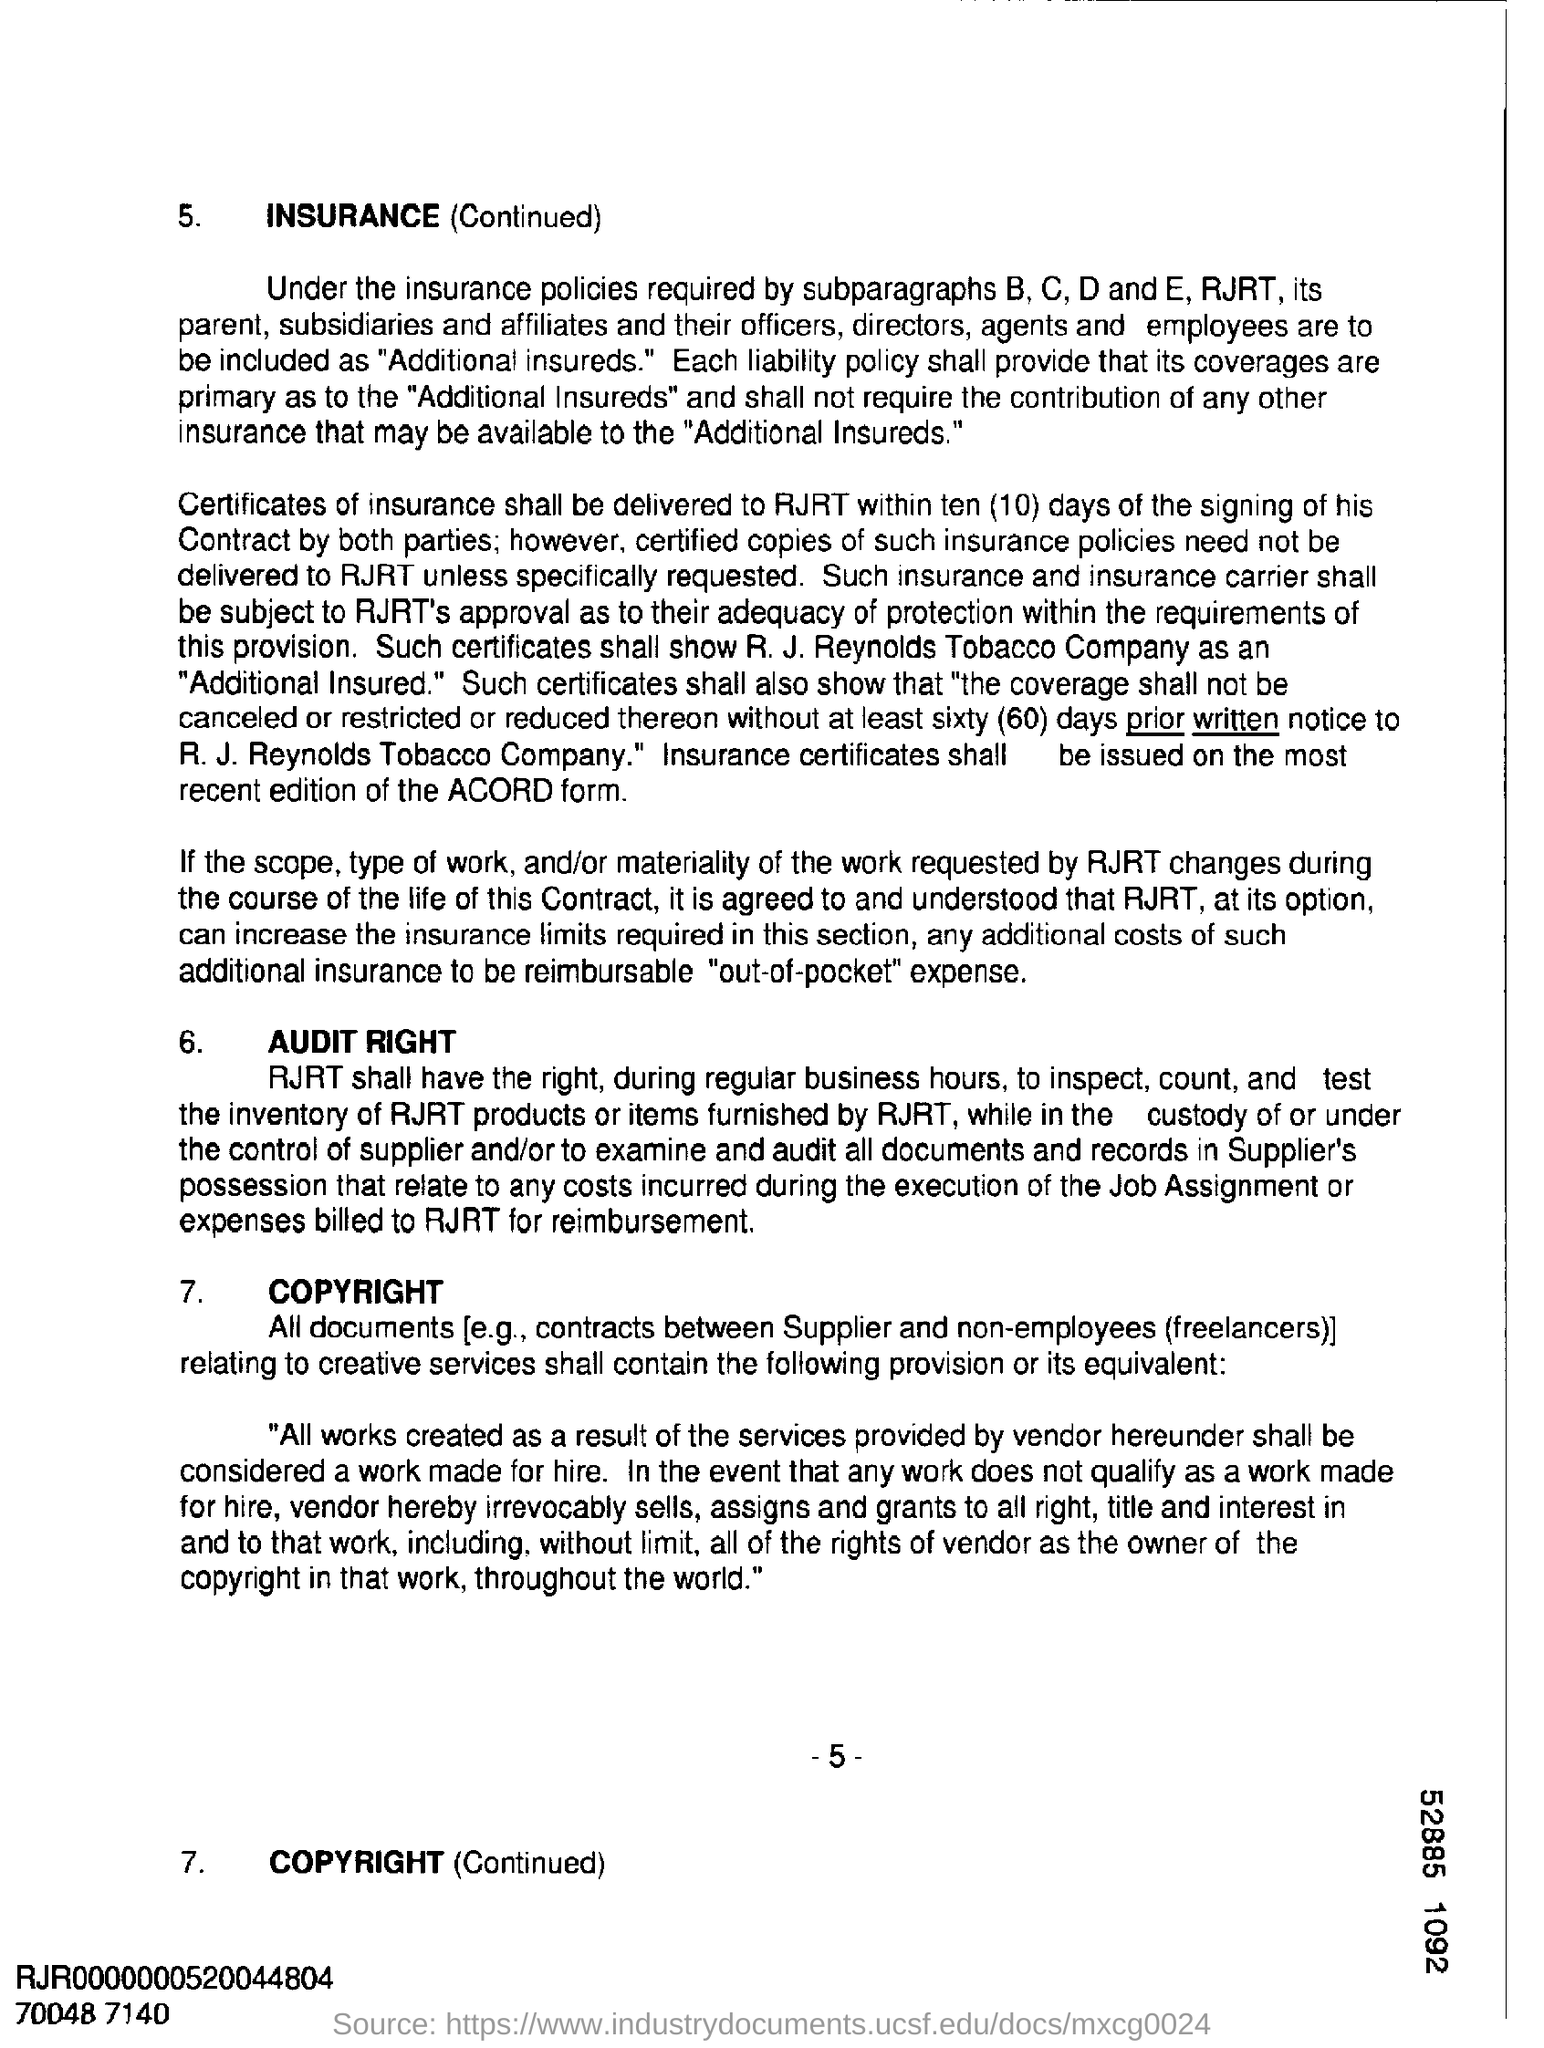What is the Page Number?
Give a very brief answer. 5. 